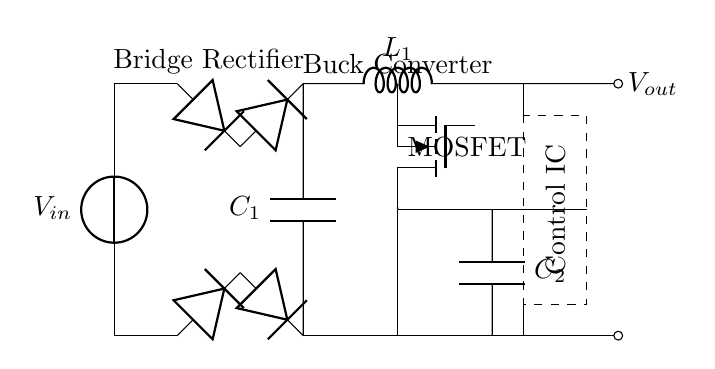What is the input voltage of the circuit? The input voltage is indicated by the label $V_{in}$ next to the voltage source at the top left of the circuit diagram.
Answer: $V_{in}$ What type of rectifier is used in the circuit? The circuit uses a bridge rectifier, which is represented by four diodes arranged in a specific formation to convert AC to DC. This is identified by the label "Bridge Rectifier" in the diagram.
Answer: Bridge Rectifier What component is used for voltage regulation in this circuit? The component responsible for voltage regulation is the MOSFET, which is identified in the circuit as 'MOSFET' and helps in managing the output voltage by switching.
Answer: MOSFET What is the function of the smoothing capacitor? The smoothing capacitor (C1) is responsible for reducing voltage ripple in the DC output after the rectifier, providing a more stable voltage. Its function can be inferred from the configuration where it is placed across the output of the bridge rectifier.
Answer: Reduces ripple How many capacitors are present in the circuit? There are two capacitors present in the circuit, which are labeled as C1 and C2; one is after the rectifier, and the other is in parallel with the output circuit.
Answer: Two What purpose does the control IC serve in this circuit? The control IC, located in the dashed rectangle labeled "Control IC," monitors the output voltage and adjusts the MOSFET operation to maintain a consistent output voltage despite variations in input or load. This can be deduced from its position and the connections leading to the MOSFET and output.
Answer: Voltage stabilization What type of converter is used in this circuit layout? The circuit utilizes a buck converter, which is indicated by the label 'Buck Converter' and is responsible for stepping down the voltage to a lower level suitable for laptop operation. It is characterized by the inductor (L1) and the configuration surrounding it.
Answer: Buck converter 